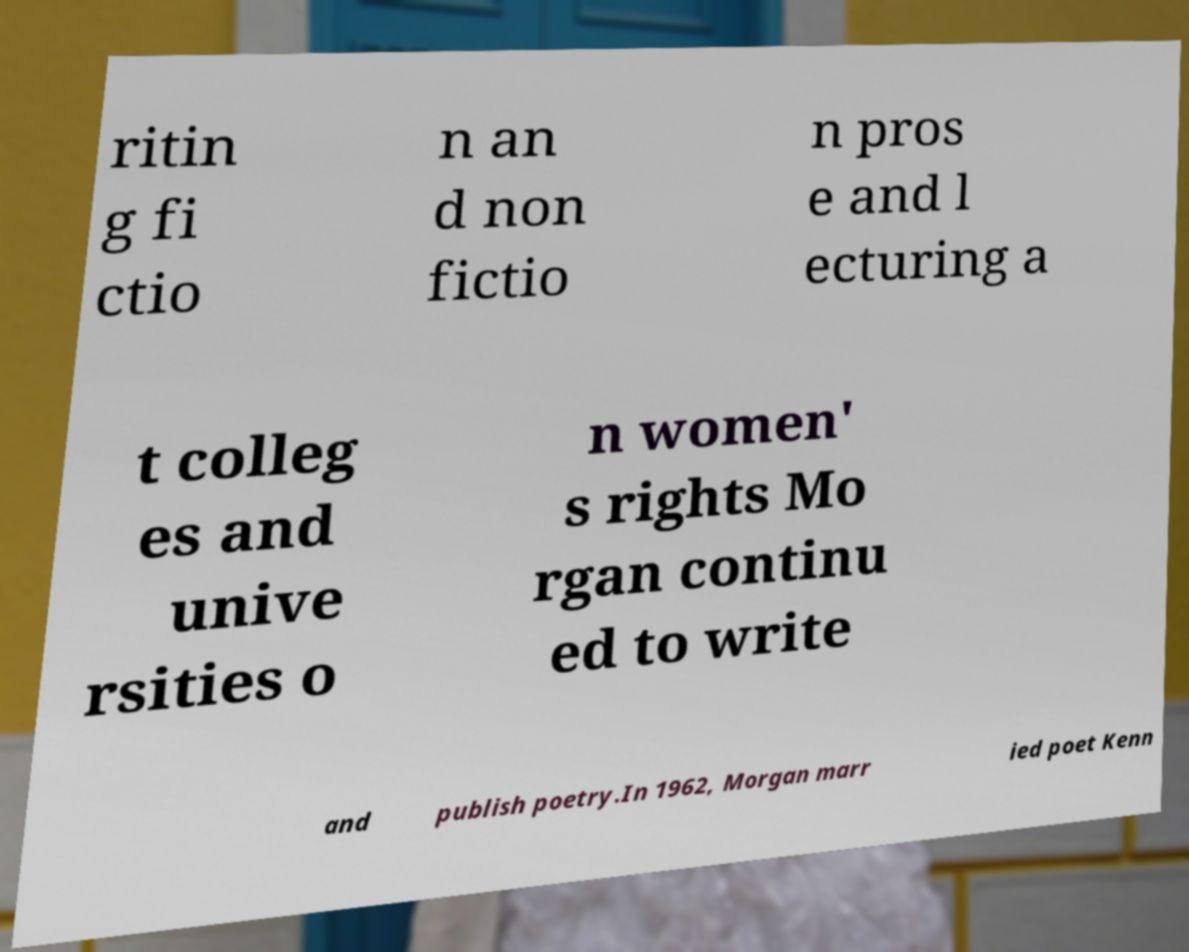Could you extract and type out the text from this image? ritin g fi ctio n an d non fictio n pros e and l ecturing a t colleg es and unive rsities o n women' s rights Mo rgan continu ed to write and publish poetry.In 1962, Morgan marr ied poet Kenn 